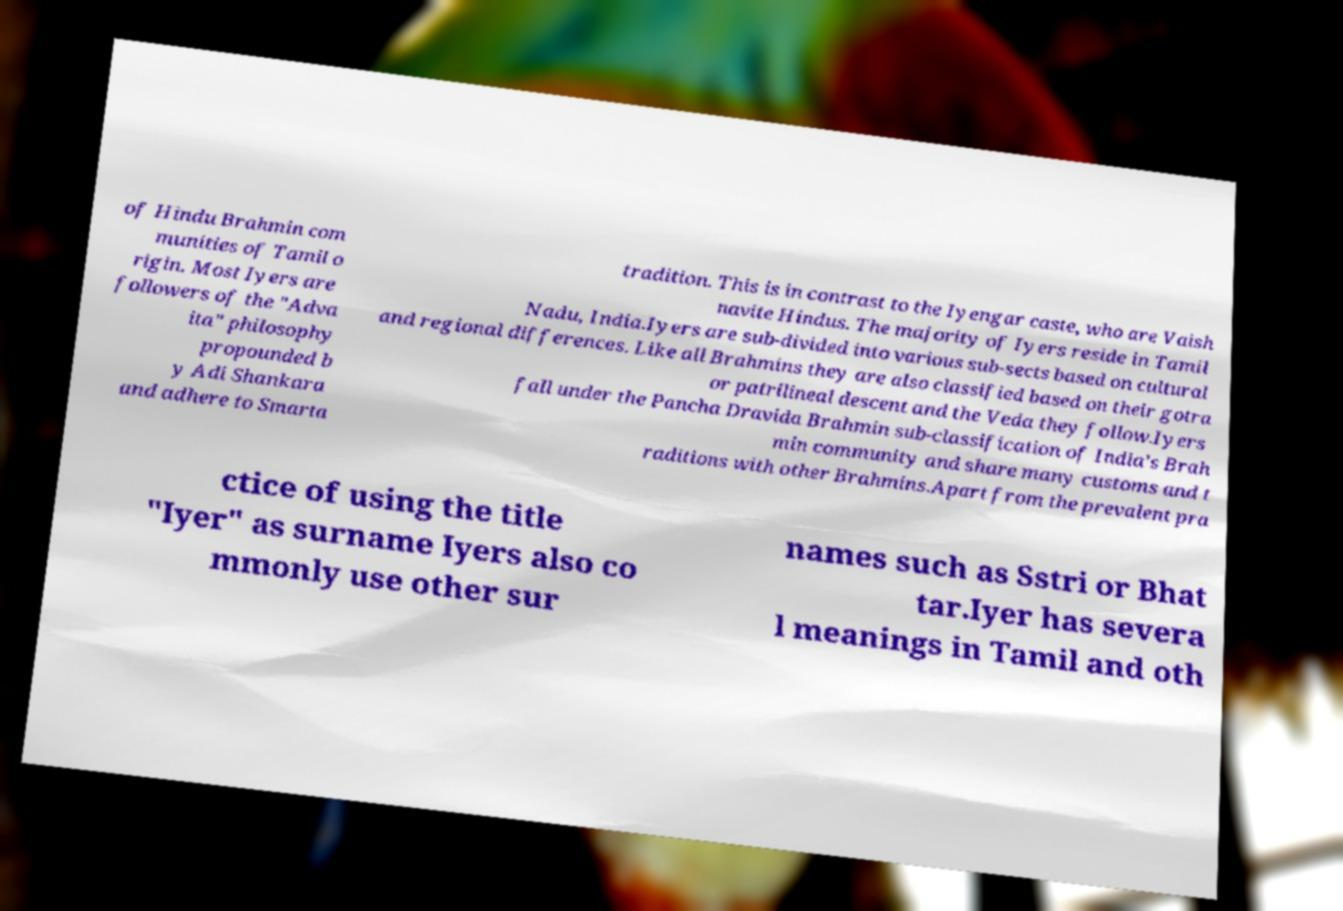Please read and relay the text visible in this image. What does it say? of Hindu Brahmin com munities of Tamil o rigin. Most Iyers are followers of the "Adva ita" philosophy propounded b y Adi Shankara and adhere to Smarta tradition. This is in contrast to the Iyengar caste, who are Vaish navite Hindus. The majority of Iyers reside in Tamil Nadu, India.Iyers are sub-divided into various sub-sects based on cultural and regional differences. Like all Brahmins they are also classified based on their gotra or patrilineal descent and the Veda they follow.Iyers fall under the Pancha Dravida Brahmin sub-classification of India's Brah min community and share many customs and t raditions with other Brahmins.Apart from the prevalent pra ctice of using the title "Iyer" as surname Iyers also co mmonly use other sur names such as Sstri or Bhat tar.Iyer has severa l meanings in Tamil and oth 